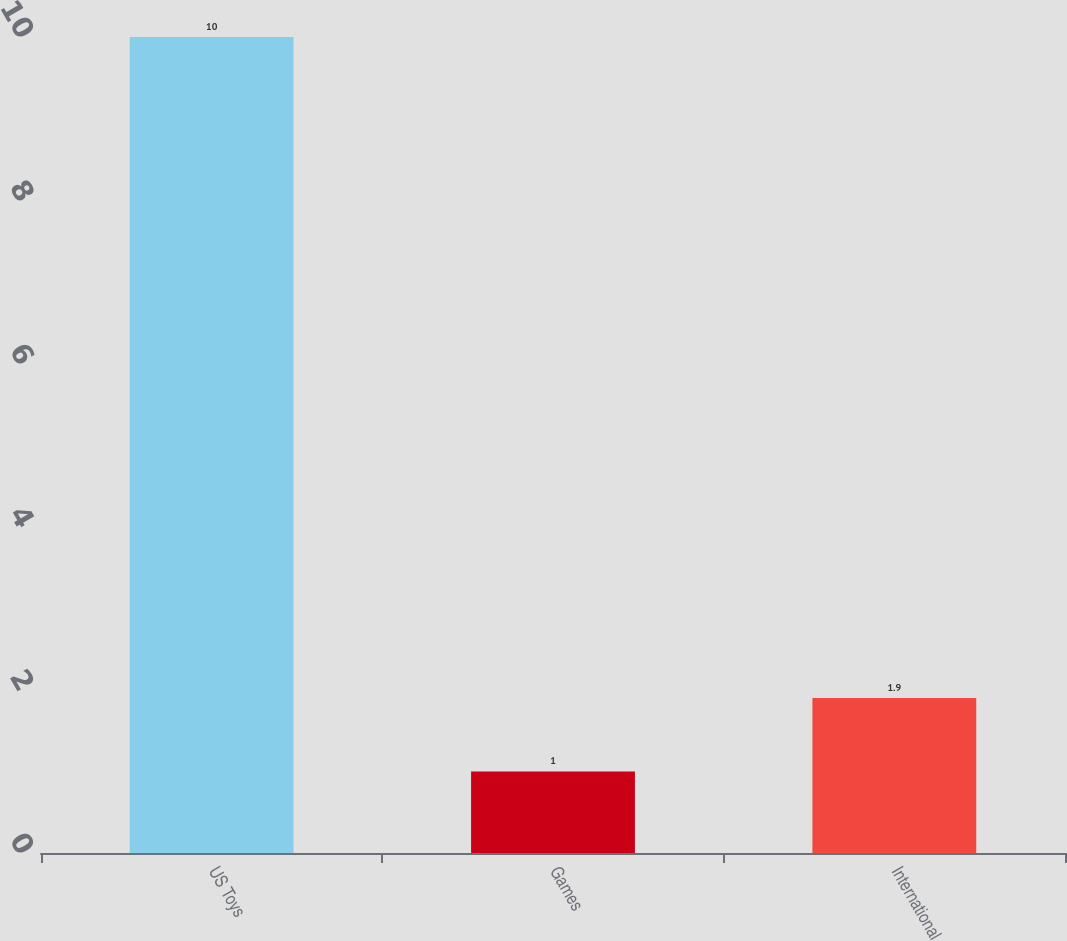<chart> <loc_0><loc_0><loc_500><loc_500><bar_chart><fcel>US Toys<fcel>Games<fcel>International<nl><fcel>10<fcel>1<fcel>1.9<nl></chart> 